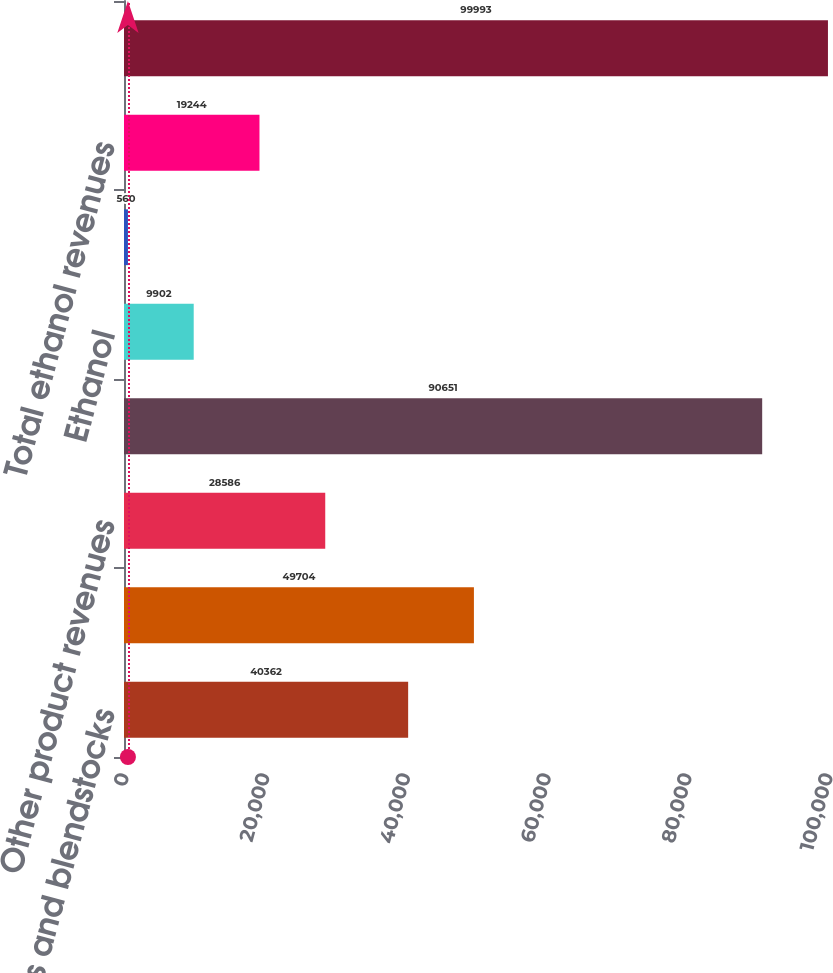Convert chart. <chart><loc_0><loc_0><loc_500><loc_500><bar_chart><fcel>Gasolines and blendstocks<fcel>Distillates<fcel>Other product revenues<fcel>Total refining revenues<fcel>Ethanol<fcel>Distillers grains<fcel>Total ethanol revenues<fcel>Total revenues from external<nl><fcel>40362<fcel>49704<fcel>28586<fcel>90651<fcel>9902<fcel>560<fcel>19244<fcel>99993<nl></chart> 